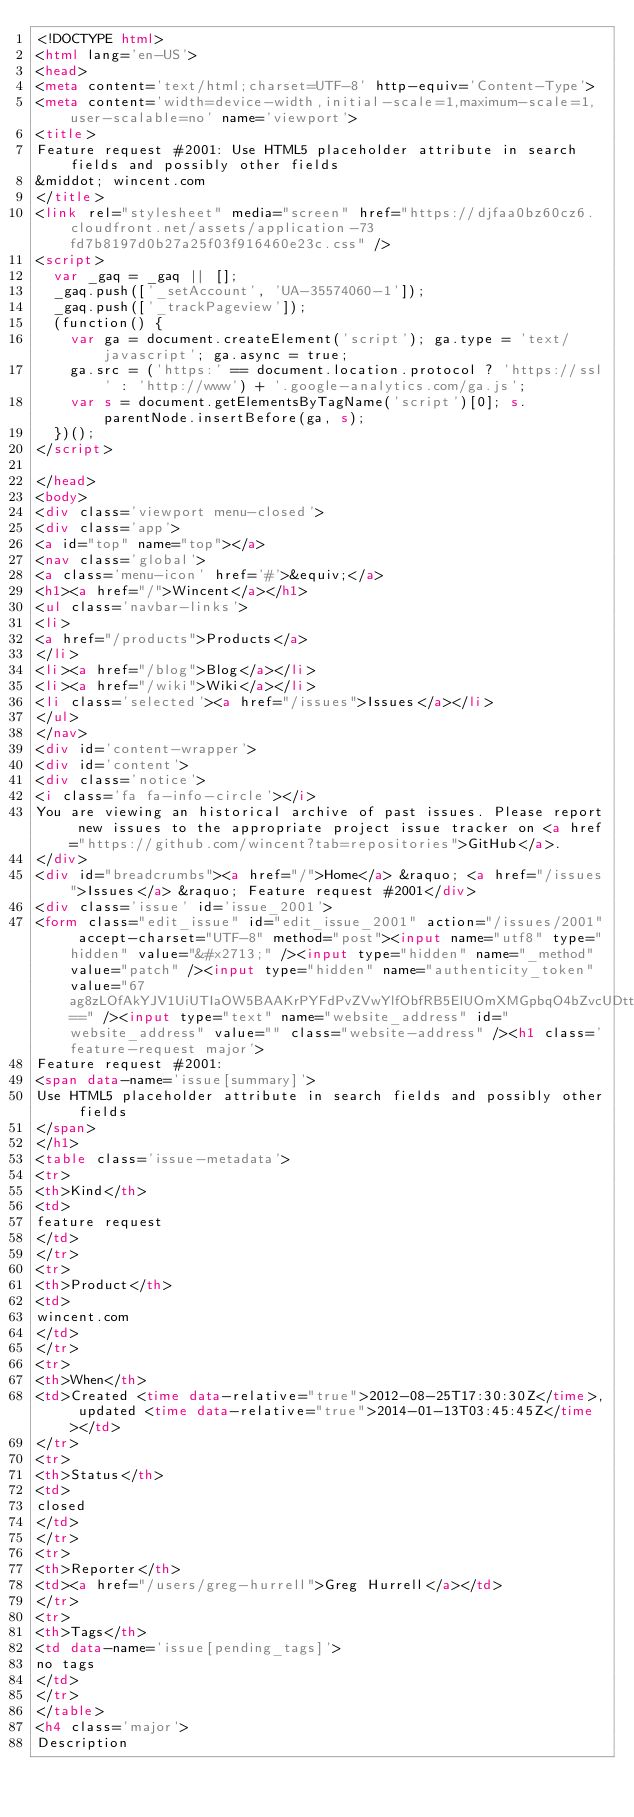Convert code to text. <code><loc_0><loc_0><loc_500><loc_500><_HTML_><!DOCTYPE html>
<html lang='en-US'>
<head>
<meta content='text/html;charset=UTF-8' http-equiv='Content-Type'>
<meta content='width=device-width,initial-scale=1,maximum-scale=1,user-scalable=no' name='viewport'>
<title>
Feature request #2001: Use HTML5 placeholder attribute in search fields and possibly other fields
&middot; wincent.com
</title>
<link rel="stylesheet" media="screen" href="https://djfaa0bz60cz6.cloudfront.net/assets/application-73fd7b8197d0b27a25f03f916460e23c.css" />
<script>
  var _gaq = _gaq || [];
  _gaq.push(['_setAccount', 'UA-35574060-1']);
  _gaq.push(['_trackPageview']);
  (function() {
    var ga = document.createElement('script'); ga.type = 'text/javascript'; ga.async = true;
    ga.src = ('https:' == document.location.protocol ? 'https://ssl' : 'http://www') + '.google-analytics.com/ga.js';
    var s = document.getElementsByTagName('script')[0]; s.parentNode.insertBefore(ga, s);
  })();
</script>

</head>
<body>
<div class='viewport menu-closed'>
<div class='app'>
<a id="top" name="top"></a>
<nav class='global'>
<a class='menu-icon' href='#'>&equiv;</a>
<h1><a href="/">Wincent</a></h1>
<ul class='navbar-links'>
<li>
<a href="/products">Products</a>
</li>
<li><a href="/blog">Blog</a></li>
<li><a href="/wiki">Wiki</a></li>
<li class='selected'><a href="/issues">Issues</a></li>
</ul>
</nav>
<div id='content-wrapper'>
<div id='content'>
<div class='notice'>
<i class='fa fa-info-circle'></i>
You are viewing an historical archive of past issues. Please report new issues to the appropriate project issue tracker on <a href="https://github.com/wincent?tab=repositories">GitHub</a>.
</div>
<div id="breadcrumbs"><a href="/">Home</a> &raquo; <a href="/issues">Issues</a> &raquo; Feature request #2001</div>
<div class='issue' id='issue_2001'>
<form class="edit_issue" id="edit_issue_2001" action="/issues/2001" accept-charset="UTF-8" method="post"><input name="utf8" type="hidden" value="&#x2713;" /><input type="hidden" name="_method" value="patch" /><input type="hidden" name="authenticity_token" value="67ag8zLOfAkYJV1UiUTIaOW5BAAKrPYFdPvZVwYlfObfRB5ElUOmXMGpbqO4bZvcUDttPAFAeBlU5AypIv0bwg==" /><input type="text" name="website_address" id="website_address" value="" class="website-address" /><h1 class='feature-request major'>
Feature request #2001:
<span data-name='issue[summary]'>
Use HTML5 placeholder attribute in search fields and possibly other fields
</span>
</h1>
<table class='issue-metadata'>
<tr>
<th>Kind</th>
<td>
feature request
</td>
</tr>
<tr>
<th>Product</th>
<td>
wincent.com
</td>
</tr>
<tr>
<th>When</th>
<td>Created <time data-relative="true">2012-08-25T17:30:30Z</time>, updated <time data-relative="true">2014-01-13T03:45:45Z</time></td>
</tr>
<tr>
<th>Status</th>
<td>
closed
</td>
</tr>
<tr>
<th>Reporter</th>
<td><a href="/users/greg-hurrell">Greg Hurrell</a></td>
</tr>
<tr>
<th>Tags</th>
<td data-name='issue[pending_tags]'>
no tags
</td>
</tr>
</table>
<h4 class='major'>
Description</code> 